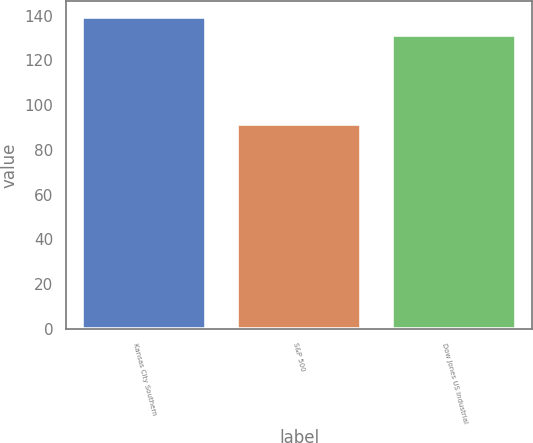Convert chart to OTSL. <chart><loc_0><loc_0><loc_500><loc_500><bar_chart><fcel>Kansas City Southern<fcel>S&P 500<fcel>Dow Jones US Industrial<nl><fcel>139.41<fcel>91.67<fcel>131.35<nl></chart> 